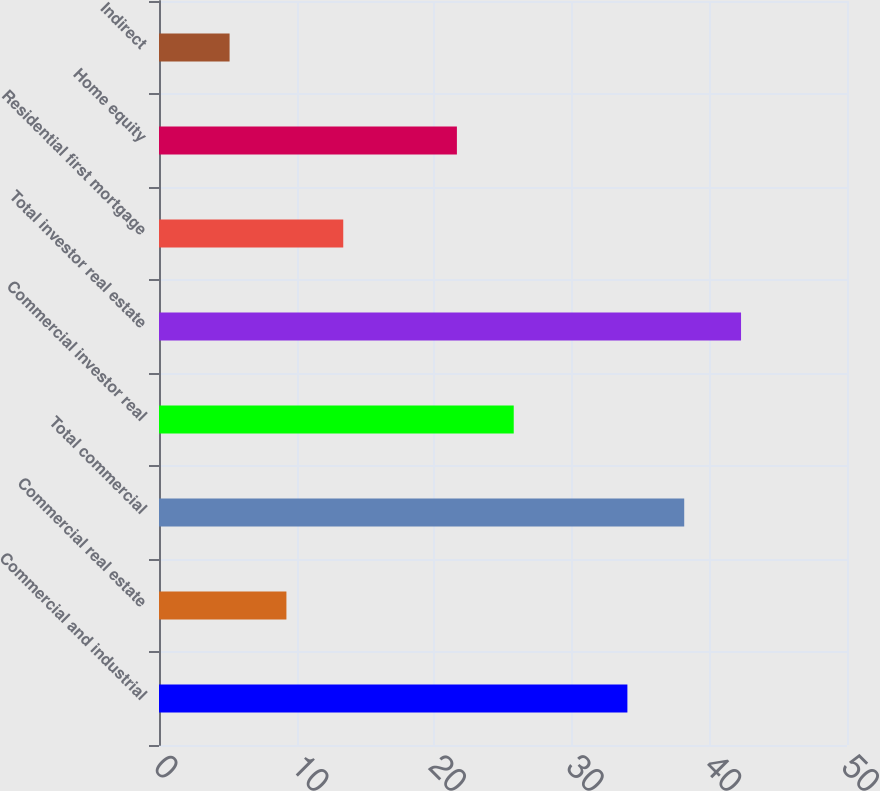Convert chart to OTSL. <chart><loc_0><loc_0><loc_500><loc_500><bar_chart><fcel>Commercial and industrial<fcel>Commercial real estate<fcel>Total commercial<fcel>Commercial investor real<fcel>Total investor real estate<fcel>Residential first mortgage<fcel>Home equity<fcel>Indirect<nl><fcel>34.04<fcel>9.26<fcel>38.17<fcel>25.78<fcel>42.3<fcel>13.39<fcel>21.65<fcel>5.13<nl></chart> 